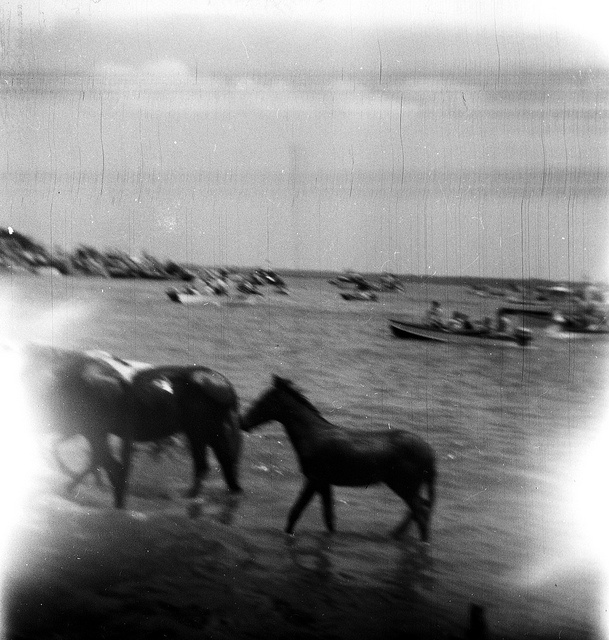Describe the objects in this image and their specific colors. I can see horse in white, black, gray, darkgray, and lightgray tones, horse in black, gray, and white tones, boat in gray, black, and white tones, boat in white, black, gray, and lightgray tones, and boat in gray, black, and white tones in this image. 